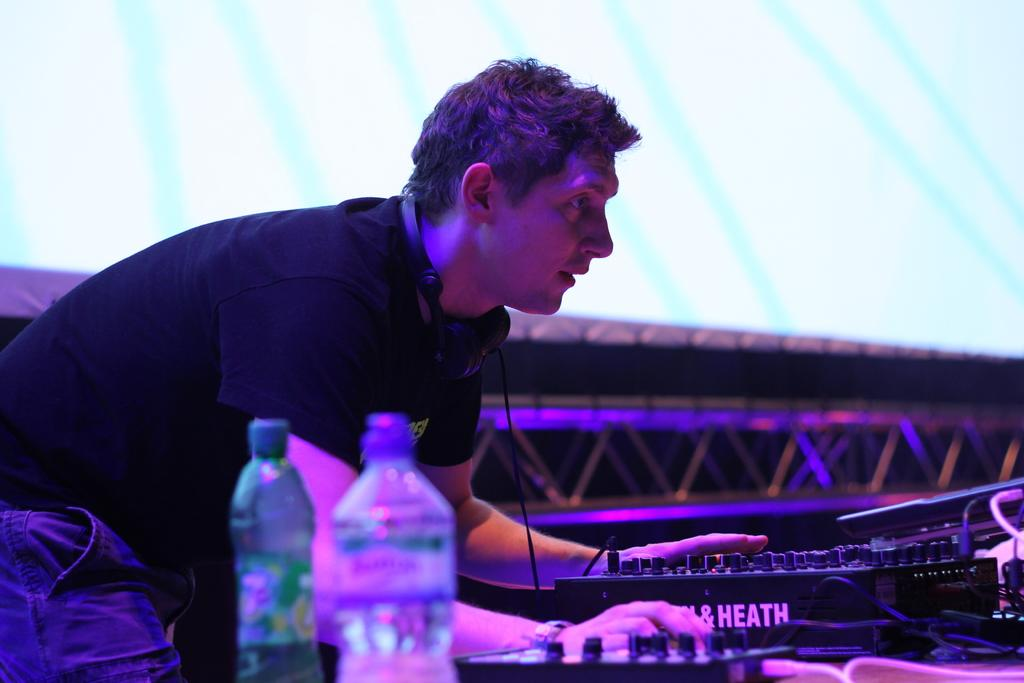Who is in the image? There is a man in the image. What is the man doing in the image? The man is bending over a table. What can be seen on the table in the image? There is electronic apparatus on the table. What type of sugar is being used to create the coil of wool in the image? There is no sugar, coil, or wool present in the image. 